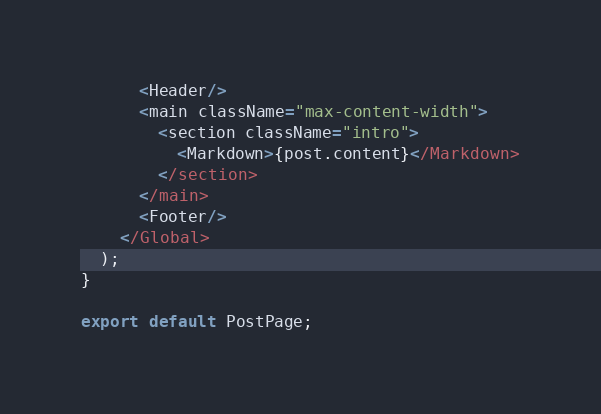Convert code to text. <code><loc_0><loc_0><loc_500><loc_500><_TypeScript_>      <Header/>
      <main className="max-content-width">
        <section className="intro">
          <Markdown>{post.content}</Markdown>
        </section>
      </main>
      <Footer/>
    </Global>
  );
}

export default PostPage;
</code> 